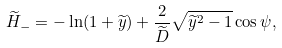<formula> <loc_0><loc_0><loc_500><loc_500>\widetilde { H } _ { - } = - \ln ( 1 + \widetilde { y } ) + \frac { 2 } { \widetilde { D } } \sqrt { \widetilde { y } ^ { 2 } - 1 } \cos \psi ,</formula> 